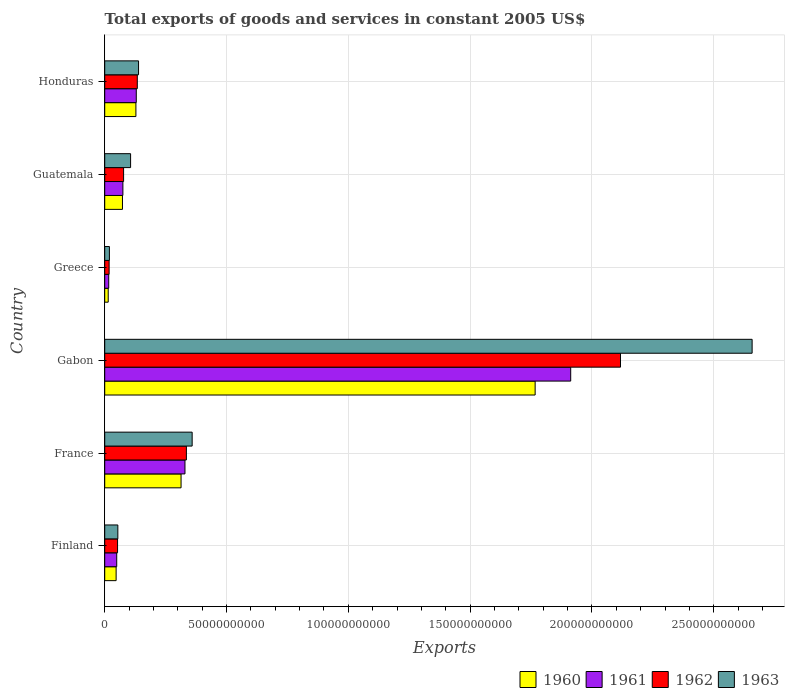How many groups of bars are there?
Your response must be concise. 6. Are the number of bars per tick equal to the number of legend labels?
Make the answer very short. Yes. Are the number of bars on each tick of the Y-axis equal?
Provide a short and direct response. Yes. How many bars are there on the 2nd tick from the bottom?
Provide a succinct answer. 4. What is the label of the 4th group of bars from the top?
Your answer should be compact. Gabon. What is the total exports of goods and services in 1961 in Gabon?
Keep it short and to the point. 1.91e+11. Across all countries, what is the maximum total exports of goods and services in 1961?
Give a very brief answer. 1.91e+11. Across all countries, what is the minimum total exports of goods and services in 1961?
Keep it short and to the point. 1.64e+09. In which country was the total exports of goods and services in 1963 maximum?
Your answer should be very brief. Gabon. In which country was the total exports of goods and services in 1961 minimum?
Provide a succinct answer. Greece. What is the total total exports of goods and services in 1962 in the graph?
Offer a very short reply. 2.73e+11. What is the difference between the total exports of goods and services in 1962 in France and that in Guatemala?
Ensure brevity in your answer.  2.58e+1. What is the difference between the total exports of goods and services in 1960 in Gabon and the total exports of goods and services in 1961 in Finland?
Ensure brevity in your answer.  1.72e+11. What is the average total exports of goods and services in 1960 per country?
Give a very brief answer. 3.90e+1. What is the difference between the total exports of goods and services in 1963 and total exports of goods and services in 1962 in Guatemala?
Your answer should be compact. 2.88e+09. In how many countries, is the total exports of goods and services in 1962 greater than 130000000000 US$?
Ensure brevity in your answer.  1. What is the ratio of the total exports of goods and services in 1963 in France to that in Guatemala?
Provide a short and direct response. 3.38. What is the difference between the highest and the second highest total exports of goods and services in 1960?
Provide a short and direct response. 1.45e+11. What is the difference between the highest and the lowest total exports of goods and services in 1962?
Your answer should be compact. 2.10e+11. Is the sum of the total exports of goods and services in 1962 in Gabon and Greece greater than the maximum total exports of goods and services in 1961 across all countries?
Offer a very short reply. Yes. Is it the case that in every country, the sum of the total exports of goods and services in 1961 and total exports of goods and services in 1960 is greater than the total exports of goods and services in 1962?
Your response must be concise. Yes. Are all the bars in the graph horizontal?
Provide a succinct answer. Yes. Where does the legend appear in the graph?
Provide a short and direct response. Bottom right. How many legend labels are there?
Provide a succinct answer. 4. How are the legend labels stacked?
Keep it short and to the point. Horizontal. What is the title of the graph?
Your answer should be compact. Total exports of goods and services in constant 2005 US$. Does "2008" appear as one of the legend labels in the graph?
Offer a very short reply. No. What is the label or title of the X-axis?
Provide a short and direct response. Exports. What is the label or title of the Y-axis?
Your answer should be very brief. Country. What is the Exports in 1960 in Finland?
Provide a succinct answer. 4.68e+09. What is the Exports in 1961 in Finland?
Your answer should be very brief. 4.92e+09. What is the Exports of 1962 in Finland?
Provide a short and direct response. 5.27e+09. What is the Exports of 1963 in Finland?
Provide a short and direct response. 5.39e+09. What is the Exports of 1960 in France?
Ensure brevity in your answer.  3.13e+1. What is the Exports of 1961 in France?
Offer a terse response. 3.29e+1. What is the Exports of 1962 in France?
Offer a terse response. 3.35e+1. What is the Exports in 1963 in France?
Your answer should be very brief. 3.59e+1. What is the Exports in 1960 in Gabon?
Make the answer very short. 1.77e+11. What is the Exports of 1961 in Gabon?
Your response must be concise. 1.91e+11. What is the Exports of 1962 in Gabon?
Offer a very short reply. 2.12e+11. What is the Exports of 1963 in Gabon?
Give a very brief answer. 2.66e+11. What is the Exports in 1960 in Greece?
Your answer should be very brief. 1.43e+09. What is the Exports in 1961 in Greece?
Offer a very short reply. 1.64e+09. What is the Exports of 1962 in Greece?
Provide a short and direct response. 1.81e+09. What is the Exports in 1963 in Greece?
Provide a succinct answer. 1.93e+09. What is the Exports of 1960 in Guatemala?
Provide a succinct answer. 7.29e+09. What is the Exports in 1961 in Guatemala?
Offer a terse response. 7.46e+09. What is the Exports in 1962 in Guatemala?
Offer a terse response. 7.75e+09. What is the Exports of 1963 in Guatemala?
Give a very brief answer. 1.06e+1. What is the Exports of 1960 in Honduras?
Offer a terse response. 1.28e+1. What is the Exports in 1961 in Honduras?
Your answer should be compact. 1.30e+1. What is the Exports in 1962 in Honduras?
Your answer should be compact. 1.34e+1. What is the Exports in 1963 in Honduras?
Offer a terse response. 1.39e+1. Across all countries, what is the maximum Exports in 1960?
Make the answer very short. 1.77e+11. Across all countries, what is the maximum Exports in 1961?
Keep it short and to the point. 1.91e+11. Across all countries, what is the maximum Exports in 1962?
Your answer should be compact. 2.12e+11. Across all countries, what is the maximum Exports in 1963?
Your response must be concise. 2.66e+11. Across all countries, what is the minimum Exports of 1960?
Make the answer very short. 1.43e+09. Across all countries, what is the minimum Exports of 1961?
Provide a short and direct response. 1.64e+09. Across all countries, what is the minimum Exports in 1962?
Your answer should be compact. 1.81e+09. Across all countries, what is the minimum Exports in 1963?
Keep it short and to the point. 1.93e+09. What is the total Exports of 1960 in the graph?
Make the answer very short. 2.34e+11. What is the total Exports in 1961 in the graph?
Ensure brevity in your answer.  2.51e+11. What is the total Exports in 1962 in the graph?
Give a very brief answer. 2.73e+11. What is the total Exports of 1963 in the graph?
Keep it short and to the point. 3.33e+11. What is the difference between the Exports in 1960 in Finland and that in France?
Offer a very short reply. -2.67e+1. What is the difference between the Exports of 1961 in Finland and that in France?
Give a very brief answer. -2.80e+1. What is the difference between the Exports in 1962 in Finland and that in France?
Ensure brevity in your answer.  -2.83e+1. What is the difference between the Exports in 1963 in Finland and that in France?
Your answer should be very brief. -3.05e+1. What is the difference between the Exports in 1960 in Finland and that in Gabon?
Provide a succinct answer. -1.72e+11. What is the difference between the Exports of 1961 in Finland and that in Gabon?
Offer a very short reply. -1.86e+11. What is the difference between the Exports of 1962 in Finland and that in Gabon?
Offer a terse response. -2.06e+11. What is the difference between the Exports in 1963 in Finland and that in Gabon?
Give a very brief answer. -2.60e+11. What is the difference between the Exports in 1960 in Finland and that in Greece?
Offer a terse response. 3.25e+09. What is the difference between the Exports of 1961 in Finland and that in Greece?
Your answer should be very brief. 3.28e+09. What is the difference between the Exports of 1962 in Finland and that in Greece?
Your response must be concise. 3.46e+09. What is the difference between the Exports in 1963 in Finland and that in Greece?
Offer a very short reply. 3.46e+09. What is the difference between the Exports in 1960 in Finland and that in Guatemala?
Your answer should be very brief. -2.61e+09. What is the difference between the Exports in 1961 in Finland and that in Guatemala?
Provide a short and direct response. -2.54e+09. What is the difference between the Exports in 1962 in Finland and that in Guatemala?
Offer a very short reply. -2.47e+09. What is the difference between the Exports of 1963 in Finland and that in Guatemala?
Make the answer very short. -5.24e+09. What is the difference between the Exports of 1960 in Finland and that in Honduras?
Offer a terse response. -8.12e+09. What is the difference between the Exports in 1961 in Finland and that in Honduras?
Provide a short and direct response. -8.03e+09. What is the difference between the Exports of 1962 in Finland and that in Honduras?
Offer a terse response. -8.10e+09. What is the difference between the Exports of 1963 in Finland and that in Honduras?
Your answer should be compact. -8.50e+09. What is the difference between the Exports in 1960 in France and that in Gabon?
Your answer should be compact. -1.45e+11. What is the difference between the Exports of 1961 in France and that in Gabon?
Provide a succinct answer. -1.58e+11. What is the difference between the Exports in 1962 in France and that in Gabon?
Provide a short and direct response. -1.78e+11. What is the difference between the Exports of 1963 in France and that in Gabon?
Your answer should be compact. -2.30e+11. What is the difference between the Exports of 1960 in France and that in Greece?
Give a very brief answer. 2.99e+1. What is the difference between the Exports in 1961 in France and that in Greece?
Offer a terse response. 3.13e+1. What is the difference between the Exports in 1962 in France and that in Greece?
Your answer should be compact. 3.17e+1. What is the difference between the Exports of 1963 in France and that in Greece?
Keep it short and to the point. 3.40e+1. What is the difference between the Exports in 1960 in France and that in Guatemala?
Make the answer very short. 2.40e+1. What is the difference between the Exports of 1961 in France and that in Guatemala?
Provide a succinct answer. 2.55e+1. What is the difference between the Exports of 1962 in France and that in Guatemala?
Your answer should be very brief. 2.58e+1. What is the difference between the Exports of 1963 in France and that in Guatemala?
Provide a short and direct response. 2.53e+1. What is the difference between the Exports of 1960 in France and that in Honduras?
Offer a very short reply. 1.85e+1. What is the difference between the Exports of 1961 in France and that in Honduras?
Your answer should be very brief. 2.00e+1. What is the difference between the Exports in 1962 in France and that in Honduras?
Give a very brief answer. 2.01e+1. What is the difference between the Exports in 1963 in France and that in Honduras?
Ensure brevity in your answer.  2.20e+1. What is the difference between the Exports of 1960 in Gabon and that in Greece?
Offer a terse response. 1.75e+11. What is the difference between the Exports in 1961 in Gabon and that in Greece?
Your answer should be compact. 1.90e+11. What is the difference between the Exports of 1962 in Gabon and that in Greece?
Offer a terse response. 2.10e+11. What is the difference between the Exports of 1963 in Gabon and that in Greece?
Provide a succinct answer. 2.64e+11. What is the difference between the Exports of 1960 in Gabon and that in Guatemala?
Offer a very short reply. 1.69e+11. What is the difference between the Exports in 1961 in Gabon and that in Guatemala?
Give a very brief answer. 1.84e+11. What is the difference between the Exports in 1962 in Gabon and that in Guatemala?
Give a very brief answer. 2.04e+11. What is the difference between the Exports of 1963 in Gabon and that in Guatemala?
Offer a terse response. 2.55e+11. What is the difference between the Exports of 1960 in Gabon and that in Honduras?
Give a very brief answer. 1.64e+11. What is the difference between the Exports of 1961 in Gabon and that in Honduras?
Keep it short and to the point. 1.78e+11. What is the difference between the Exports in 1962 in Gabon and that in Honduras?
Provide a succinct answer. 1.98e+11. What is the difference between the Exports of 1963 in Gabon and that in Honduras?
Keep it short and to the point. 2.52e+11. What is the difference between the Exports of 1960 in Greece and that in Guatemala?
Ensure brevity in your answer.  -5.85e+09. What is the difference between the Exports of 1961 in Greece and that in Guatemala?
Keep it short and to the point. -5.82e+09. What is the difference between the Exports in 1962 in Greece and that in Guatemala?
Provide a short and direct response. -5.94e+09. What is the difference between the Exports of 1963 in Greece and that in Guatemala?
Make the answer very short. -8.70e+09. What is the difference between the Exports of 1960 in Greece and that in Honduras?
Your answer should be compact. -1.14e+1. What is the difference between the Exports in 1961 in Greece and that in Honduras?
Make the answer very short. -1.13e+1. What is the difference between the Exports of 1962 in Greece and that in Honduras?
Provide a succinct answer. -1.16e+1. What is the difference between the Exports in 1963 in Greece and that in Honduras?
Offer a terse response. -1.20e+1. What is the difference between the Exports of 1960 in Guatemala and that in Honduras?
Your answer should be very brief. -5.51e+09. What is the difference between the Exports of 1961 in Guatemala and that in Honduras?
Offer a terse response. -5.49e+09. What is the difference between the Exports in 1962 in Guatemala and that in Honduras?
Offer a terse response. -5.63e+09. What is the difference between the Exports in 1963 in Guatemala and that in Honduras?
Ensure brevity in your answer.  -3.26e+09. What is the difference between the Exports in 1960 in Finland and the Exports in 1961 in France?
Keep it short and to the point. -2.83e+1. What is the difference between the Exports of 1960 in Finland and the Exports of 1962 in France?
Provide a short and direct response. -2.88e+1. What is the difference between the Exports of 1960 in Finland and the Exports of 1963 in France?
Your answer should be very brief. -3.12e+1. What is the difference between the Exports of 1961 in Finland and the Exports of 1962 in France?
Give a very brief answer. -2.86e+1. What is the difference between the Exports in 1961 in Finland and the Exports in 1963 in France?
Ensure brevity in your answer.  -3.10e+1. What is the difference between the Exports of 1962 in Finland and the Exports of 1963 in France?
Your response must be concise. -3.06e+1. What is the difference between the Exports in 1960 in Finland and the Exports in 1961 in Gabon?
Offer a very short reply. -1.87e+11. What is the difference between the Exports of 1960 in Finland and the Exports of 1962 in Gabon?
Give a very brief answer. -2.07e+11. What is the difference between the Exports in 1960 in Finland and the Exports in 1963 in Gabon?
Offer a terse response. -2.61e+11. What is the difference between the Exports in 1961 in Finland and the Exports in 1962 in Gabon?
Your response must be concise. -2.07e+11. What is the difference between the Exports in 1961 in Finland and the Exports in 1963 in Gabon?
Ensure brevity in your answer.  -2.61e+11. What is the difference between the Exports in 1962 in Finland and the Exports in 1963 in Gabon?
Keep it short and to the point. -2.60e+11. What is the difference between the Exports of 1960 in Finland and the Exports of 1961 in Greece?
Provide a short and direct response. 3.04e+09. What is the difference between the Exports in 1960 in Finland and the Exports in 1962 in Greece?
Give a very brief answer. 2.88e+09. What is the difference between the Exports in 1960 in Finland and the Exports in 1963 in Greece?
Give a very brief answer. 2.76e+09. What is the difference between the Exports of 1961 in Finland and the Exports of 1962 in Greece?
Provide a short and direct response. 3.12e+09. What is the difference between the Exports in 1961 in Finland and the Exports in 1963 in Greece?
Provide a succinct answer. 3.00e+09. What is the difference between the Exports in 1962 in Finland and the Exports in 1963 in Greece?
Make the answer very short. 3.34e+09. What is the difference between the Exports in 1960 in Finland and the Exports in 1961 in Guatemala?
Offer a terse response. -2.78e+09. What is the difference between the Exports in 1960 in Finland and the Exports in 1962 in Guatemala?
Your response must be concise. -3.06e+09. What is the difference between the Exports in 1960 in Finland and the Exports in 1963 in Guatemala?
Provide a short and direct response. -5.94e+09. What is the difference between the Exports of 1961 in Finland and the Exports of 1962 in Guatemala?
Offer a very short reply. -2.82e+09. What is the difference between the Exports of 1961 in Finland and the Exports of 1963 in Guatemala?
Your answer should be compact. -5.70e+09. What is the difference between the Exports in 1962 in Finland and the Exports in 1963 in Guatemala?
Offer a terse response. -5.35e+09. What is the difference between the Exports in 1960 in Finland and the Exports in 1961 in Honduras?
Ensure brevity in your answer.  -8.27e+09. What is the difference between the Exports in 1960 in Finland and the Exports in 1962 in Honduras?
Your answer should be very brief. -8.69e+09. What is the difference between the Exports in 1960 in Finland and the Exports in 1963 in Honduras?
Your answer should be compact. -9.20e+09. What is the difference between the Exports of 1961 in Finland and the Exports of 1962 in Honduras?
Provide a short and direct response. -8.45e+09. What is the difference between the Exports of 1961 in Finland and the Exports of 1963 in Honduras?
Provide a short and direct response. -8.96e+09. What is the difference between the Exports in 1962 in Finland and the Exports in 1963 in Honduras?
Keep it short and to the point. -8.61e+09. What is the difference between the Exports of 1960 in France and the Exports of 1961 in Gabon?
Your answer should be very brief. -1.60e+11. What is the difference between the Exports of 1960 in France and the Exports of 1962 in Gabon?
Your answer should be very brief. -1.80e+11. What is the difference between the Exports of 1960 in France and the Exports of 1963 in Gabon?
Keep it short and to the point. -2.34e+11. What is the difference between the Exports in 1961 in France and the Exports in 1962 in Gabon?
Ensure brevity in your answer.  -1.79e+11. What is the difference between the Exports of 1961 in France and the Exports of 1963 in Gabon?
Provide a short and direct response. -2.33e+11. What is the difference between the Exports of 1962 in France and the Exports of 1963 in Gabon?
Offer a terse response. -2.32e+11. What is the difference between the Exports in 1960 in France and the Exports in 1961 in Greece?
Ensure brevity in your answer.  2.97e+1. What is the difference between the Exports of 1960 in France and the Exports of 1962 in Greece?
Your answer should be compact. 2.95e+1. What is the difference between the Exports of 1960 in France and the Exports of 1963 in Greece?
Ensure brevity in your answer.  2.94e+1. What is the difference between the Exports in 1961 in France and the Exports in 1962 in Greece?
Keep it short and to the point. 3.11e+1. What is the difference between the Exports in 1961 in France and the Exports in 1963 in Greece?
Ensure brevity in your answer.  3.10e+1. What is the difference between the Exports in 1962 in France and the Exports in 1963 in Greece?
Provide a short and direct response. 3.16e+1. What is the difference between the Exports of 1960 in France and the Exports of 1961 in Guatemala?
Your response must be concise. 2.39e+1. What is the difference between the Exports in 1960 in France and the Exports in 1962 in Guatemala?
Offer a terse response. 2.36e+1. What is the difference between the Exports of 1960 in France and the Exports of 1963 in Guatemala?
Provide a short and direct response. 2.07e+1. What is the difference between the Exports of 1961 in France and the Exports of 1962 in Guatemala?
Offer a terse response. 2.52e+1. What is the difference between the Exports of 1961 in France and the Exports of 1963 in Guatemala?
Offer a very short reply. 2.23e+1. What is the difference between the Exports in 1962 in France and the Exports in 1963 in Guatemala?
Give a very brief answer. 2.29e+1. What is the difference between the Exports of 1960 in France and the Exports of 1961 in Honduras?
Your response must be concise. 1.84e+1. What is the difference between the Exports in 1960 in France and the Exports in 1962 in Honduras?
Give a very brief answer. 1.80e+1. What is the difference between the Exports of 1960 in France and the Exports of 1963 in Honduras?
Keep it short and to the point. 1.74e+1. What is the difference between the Exports of 1961 in France and the Exports of 1962 in Honduras?
Keep it short and to the point. 1.96e+1. What is the difference between the Exports in 1961 in France and the Exports in 1963 in Honduras?
Make the answer very short. 1.91e+1. What is the difference between the Exports in 1962 in France and the Exports in 1963 in Honduras?
Make the answer very short. 1.96e+1. What is the difference between the Exports of 1960 in Gabon and the Exports of 1961 in Greece?
Your answer should be compact. 1.75e+11. What is the difference between the Exports in 1960 in Gabon and the Exports in 1962 in Greece?
Provide a succinct answer. 1.75e+11. What is the difference between the Exports of 1960 in Gabon and the Exports of 1963 in Greece?
Make the answer very short. 1.75e+11. What is the difference between the Exports in 1961 in Gabon and the Exports in 1962 in Greece?
Ensure brevity in your answer.  1.89e+11. What is the difference between the Exports of 1961 in Gabon and the Exports of 1963 in Greece?
Provide a short and direct response. 1.89e+11. What is the difference between the Exports in 1962 in Gabon and the Exports in 1963 in Greece?
Your response must be concise. 2.10e+11. What is the difference between the Exports of 1960 in Gabon and the Exports of 1961 in Guatemala?
Give a very brief answer. 1.69e+11. What is the difference between the Exports in 1960 in Gabon and the Exports in 1962 in Guatemala?
Your response must be concise. 1.69e+11. What is the difference between the Exports of 1960 in Gabon and the Exports of 1963 in Guatemala?
Give a very brief answer. 1.66e+11. What is the difference between the Exports of 1961 in Gabon and the Exports of 1962 in Guatemala?
Your answer should be very brief. 1.84e+11. What is the difference between the Exports in 1961 in Gabon and the Exports in 1963 in Guatemala?
Your response must be concise. 1.81e+11. What is the difference between the Exports of 1962 in Gabon and the Exports of 1963 in Guatemala?
Keep it short and to the point. 2.01e+11. What is the difference between the Exports of 1960 in Gabon and the Exports of 1961 in Honduras?
Your response must be concise. 1.64e+11. What is the difference between the Exports of 1960 in Gabon and the Exports of 1962 in Honduras?
Your response must be concise. 1.63e+11. What is the difference between the Exports in 1960 in Gabon and the Exports in 1963 in Honduras?
Provide a succinct answer. 1.63e+11. What is the difference between the Exports of 1961 in Gabon and the Exports of 1962 in Honduras?
Provide a short and direct response. 1.78e+11. What is the difference between the Exports of 1961 in Gabon and the Exports of 1963 in Honduras?
Keep it short and to the point. 1.77e+11. What is the difference between the Exports of 1962 in Gabon and the Exports of 1963 in Honduras?
Keep it short and to the point. 1.98e+11. What is the difference between the Exports in 1960 in Greece and the Exports in 1961 in Guatemala?
Make the answer very short. -6.02e+09. What is the difference between the Exports in 1960 in Greece and the Exports in 1962 in Guatemala?
Your answer should be compact. -6.31e+09. What is the difference between the Exports in 1960 in Greece and the Exports in 1963 in Guatemala?
Make the answer very short. -9.19e+09. What is the difference between the Exports in 1961 in Greece and the Exports in 1962 in Guatemala?
Offer a very short reply. -6.10e+09. What is the difference between the Exports in 1961 in Greece and the Exports in 1963 in Guatemala?
Make the answer very short. -8.98e+09. What is the difference between the Exports of 1962 in Greece and the Exports of 1963 in Guatemala?
Offer a terse response. -8.82e+09. What is the difference between the Exports of 1960 in Greece and the Exports of 1961 in Honduras?
Keep it short and to the point. -1.15e+1. What is the difference between the Exports of 1960 in Greece and the Exports of 1962 in Honduras?
Make the answer very short. -1.19e+1. What is the difference between the Exports in 1960 in Greece and the Exports in 1963 in Honduras?
Your answer should be compact. -1.25e+1. What is the difference between the Exports of 1961 in Greece and the Exports of 1962 in Honduras?
Provide a succinct answer. -1.17e+1. What is the difference between the Exports of 1961 in Greece and the Exports of 1963 in Honduras?
Keep it short and to the point. -1.22e+1. What is the difference between the Exports in 1962 in Greece and the Exports in 1963 in Honduras?
Provide a succinct answer. -1.21e+1. What is the difference between the Exports in 1960 in Guatemala and the Exports in 1961 in Honduras?
Your answer should be compact. -5.66e+09. What is the difference between the Exports in 1960 in Guatemala and the Exports in 1962 in Honduras?
Offer a terse response. -6.09e+09. What is the difference between the Exports in 1960 in Guatemala and the Exports in 1963 in Honduras?
Give a very brief answer. -6.60e+09. What is the difference between the Exports of 1961 in Guatemala and the Exports of 1962 in Honduras?
Provide a succinct answer. -5.92e+09. What is the difference between the Exports in 1961 in Guatemala and the Exports in 1963 in Honduras?
Provide a succinct answer. -6.43e+09. What is the difference between the Exports of 1962 in Guatemala and the Exports of 1963 in Honduras?
Give a very brief answer. -6.14e+09. What is the average Exports in 1960 per country?
Your answer should be compact. 3.90e+1. What is the average Exports in 1961 per country?
Your response must be concise. 4.19e+1. What is the average Exports of 1962 per country?
Your response must be concise. 4.56e+1. What is the average Exports in 1963 per country?
Your answer should be compact. 5.56e+1. What is the difference between the Exports of 1960 and Exports of 1961 in Finland?
Provide a succinct answer. -2.41e+08. What is the difference between the Exports in 1960 and Exports in 1962 in Finland?
Give a very brief answer. -5.89e+08. What is the difference between the Exports in 1960 and Exports in 1963 in Finland?
Your answer should be compact. -7.04e+08. What is the difference between the Exports in 1961 and Exports in 1962 in Finland?
Provide a short and direct response. -3.48e+08. What is the difference between the Exports of 1961 and Exports of 1963 in Finland?
Offer a very short reply. -4.64e+08. What is the difference between the Exports of 1962 and Exports of 1963 in Finland?
Your answer should be very brief. -1.15e+08. What is the difference between the Exports in 1960 and Exports in 1961 in France?
Your answer should be compact. -1.60e+09. What is the difference between the Exports of 1960 and Exports of 1962 in France?
Keep it short and to the point. -2.19e+09. What is the difference between the Exports in 1960 and Exports in 1963 in France?
Your answer should be compact. -4.55e+09. What is the difference between the Exports of 1961 and Exports of 1962 in France?
Make the answer very short. -5.82e+08. What is the difference between the Exports in 1961 and Exports in 1963 in France?
Your response must be concise. -2.95e+09. What is the difference between the Exports of 1962 and Exports of 1963 in France?
Give a very brief answer. -2.37e+09. What is the difference between the Exports of 1960 and Exports of 1961 in Gabon?
Your answer should be very brief. -1.46e+1. What is the difference between the Exports of 1960 and Exports of 1962 in Gabon?
Keep it short and to the point. -3.50e+1. What is the difference between the Exports of 1960 and Exports of 1963 in Gabon?
Your answer should be compact. -8.91e+1. What is the difference between the Exports in 1961 and Exports in 1962 in Gabon?
Give a very brief answer. -2.04e+1. What is the difference between the Exports of 1961 and Exports of 1963 in Gabon?
Make the answer very short. -7.45e+1. What is the difference between the Exports in 1962 and Exports in 1963 in Gabon?
Give a very brief answer. -5.40e+1. What is the difference between the Exports in 1960 and Exports in 1961 in Greece?
Keep it short and to the point. -2.08e+08. What is the difference between the Exports of 1960 and Exports of 1962 in Greece?
Your answer should be compact. -3.72e+08. What is the difference between the Exports in 1960 and Exports in 1963 in Greece?
Give a very brief answer. -4.92e+08. What is the difference between the Exports of 1961 and Exports of 1962 in Greece?
Provide a succinct answer. -1.64e+08. What is the difference between the Exports of 1961 and Exports of 1963 in Greece?
Make the answer very short. -2.84e+08. What is the difference between the Exports in 1962 and Exports in 1963 in Greece?
Ensure brevity in your answer.  -1.20e+08. What is the difference between the Exports in 1960 and Exports in 1961 in Guatemala?
Your answer should be very brief. -1.71e+08. What is the difference between the Exports in 1960 and Exports in 1962 in Guatemala?
Provide a short and direct response. -4.57e+08. What is the difference between the Exports in 1960 and Exports in 1963 in Guatemala?
Your answer should be compact. -3.33e+09. What is the difference between the Exports of 1961 and Exports of 1962 in Guatemala?
Provide a succinct answer. -2.86e+08. What is the difference between the Exports of 1961 and Exports of 1963 in Guatemala?
Provide a short and direct response. -3.16e+09. What is the difference between the Exports in 1962 and Exports in 1963 in Guatemala?
Ensure brevity in your answer.  -2.88e+09. What is the difference between the Exports in 1960 and Exports in 1961 in Honduras?
Your answer should be very brief. -1.52e+08. What is the difference between the Exports in 1960 and Exports in 1962 in Honduras?
Offer a very short reply. -5.74e+08. What is the difference between the Exports of 1960 and Exports of 1963 in Honduras?
Offer a terse response. -1.09e+09. What is the difference between the Exports of 1961 and Exports of 1962 in Honduras?
Your answer should be compact. -4.22e+08. What is the difference between the Exports in 1961 and Exports in 1963 in Honduras?
Your answer should be very brief. -9.34e+08. What is the difference between the Exports of 1962 and Exports of 1963 in Honduras?
Your response must be concise. -5.12e+08. What is the ratio of the Exports of 1960 in Finland to that in France?
Your response must be concise. 0.15. What is the ratio of the Exports in 1961 in Finland to that in France?
Your response must be concise. 0.15. What is the ratio of the Exports of 1962 in Finland to that in France?
Provide a short and direct response. 0.16. What is the ratio of the Exports in 1963 in Finland to that in France?
Provide a succinct answer. 0.15. What is the ratio of the Exports in 1960 in Finland to that in Gabon?
Give a very brief answer. 0.03. What is the ratio of the Exports in 1961 in Finland to that in Gabon?
Your answer should be very brief. 0.03. What is the ratio of the Exports of 1962 in Finland to that in Gabon?
Your response must be concise. 0.02. What is the ratio of the Exports of 1963 in Finland to that in Gabon?
Provide a short and direct response. 0.02. What is the ratio of the Exports in 1960 in Finland to that in Greece?
Your answer should be compact. 3.26. What is the ratio of the Exports in 1961 in Finland to that in Greece?
Offer a very short reply. 3. What is the ratio of the Exports in 1962 in Finland to that in Greece?
Your response must be concise. 2.92. What is the ratio of the Exports of 1963 in Finland to that in Greece?
Provide a short and direct response. 2.8. What is the ratio of the Exports in 1960 in Finland to that in Guatemala?
Your response must be concise. 0.64. What is the ratio of the Exports of 1961 in Finland to that in Guatemala?
Ensure brevity in your answer.  0.66. What is the ratio of the Exports of 1962 in Finland to that in Guatemala?
Offer a very short reply. 0.68. What is the ratio of the Exports of 1963 in Finland to that in Guatemala?
Your answer should be very brief. 0.51. What is the ratio of the Exports of 1960 in Finland to that in Honduras?
Offer a terse response. 0.37. What is the ratio of the Exports of 1961 in Finland to that in Honduras?
Offer a very short reply. 0.38. What is the ratio of the Exports of 1962 in Finland to that in Honduras?
Your answer should be compact. 0.39. What is the ratio of the Exports of 1963 in Finland to that in Honduras?
Keep it short and to the point. 0.39. What is the ratio of the Exports of 1960 in France to that in Gabon?
Offer a terse response. 0.18. What is the ratio of the Exports in 1961 in France to that in Gabon?
Your answer should be very brief. 0.17. What is the ratio of the Exports of 1962 in France to that in Gabon?
Offer a terse response. 0.16. What is the ratio of the Exports of 1963 in France to that in Gabon?
Offer a terse response. 0.14. What is the ratio of the Exports of 1960 in France to that in Greece?
Your answer should be compact. 21.84. What is the ratio of the Exports in 1961 in France to that in Greece?
Offer a terse response. 20.05. What is the ratio of the Exports in 1962 in France to that in Greece?
Provide a short and direct response. 18.55. What is the ratio of the Exports of 1963 in France to that in Greece?
Your answer should be compact. 18.62. What is the ratio of the Exports in 1960 in France to that in Guatemala?
Make the answer very short. 4.3. What is the ratio of the Exports of 1961 in France to that in Guatemala?
Your response must be concise. 4.42. What is the ratio of the Exports of 1962 in France to that in Guatemala?
Your answer should be compact. 4.33. What is the ratio of the Exports in 1963 in France to that in Guatemala?
Provide a succinct answer. 3.38. What is the ratio of the Exports in 1960 in France to that in Honduras?
Provide a succinct answer. 2.45. What is the ratio of the Exports of 1961 in France to that in Honduras?
Your answer should be compact. 2.54. What is the ratio of the Exports in 1962 in France to that in Honduras?
Ensure brevity in your answer.  2.51. What is the ratio of the Exports in 1963 in France to that in Honduras?
Keep it short and to the point. 2.58. What is the ratio of the Exports of 1960 in Gabon to that in Greece?
Keep it short and to the point. 123.12. What is the ratio of the Exports in 1961 in Gabon to that in Greece?
Offer a terse response. 116.39. What is the ratio of the Exports in 1962 in Gabon to that in Greece?
Keep it short and to the point. 117.16. What is the ratio of the Exports of 1963 in Gabon to that in Greece?
Your answer should be compact. 137.87. What is the ratio of the Exports of 1960 in Gabon to that in Guatemala?
Your response must be concise. 24.24. What is the ratio of the Exports in 1961 in Gabon to that in Guatemala?
Provide a short and direct response. 25.64. What is the ratio of the Exports of 1962 in Gabon to that in Guatemala?
Provide a short and direct response. 27.33. What is the ratio of the Exports in 1963 in Gabon to that in Guatemala?
Offer a terse response. 25.02. What is the ratio of the Exports of 1960 in Gabon to that in Honduras?
Provide a short and direct response. 13.8. What is the ratio of the Exports of 1961 in Gabon to that in Honduras?
Offer a very short reply. 14.77. What is the ratio of the Exports of 1962 in Gabon to that in Honduras?
Give a very brief answer. 15.83. What is the ratio of the Exports in 1963 in Gabon to that in Honduras?
Your answer should be compact. 19.14. What is the ratio of the Exports of 1960 in Greece to that in Guatemala?
Offer a very short reply. 0.2. What is the ratio of the Exports in 1961 in Greece to that in Guatemala?
Your response must be concise. 0.22. What is the ratio of the Exports of 1962 in Greece to that in Guatemala?
Provide a succinct answer. 0.23. What is the ratio of the Exports of 1963 in Greece to that in Guatemala?
Make the answer very short. 0.18. What is the ratio of the Exports of 1960 in Greece to that in Honduras?
Your answer should be compact. 0.11. What is the ratio of the Exports of 1961 in Greece to that in Honduras?
Offer a terse response. 0.13. What is the ratio of the Exports of 1962 in Greece to that in Honduras?
Keep it short and to the point. 0.14. What is the ratio of the Exports of 1963 in Greece to that in Honduras?
Your answer should be compact. 0.14. What is the ratio of the Exports in 1960 in Guatemala to that in Honduras?
Provide a succinct answer. 0.57. What is the ratio of the Exports of 1961 in Guatemala to that in Honduras?
Make the answer very short. 0.58. What is the ratio of the Exports of 1962 in Guatemala to that in Honduras?
Offer a terse response. 0.58. What is the ratio of the Exports in 1963 in Guatemala to that in Honduras?
Give a very brief answer. 0.76. What is the difference between the highest and the second highest Exports in 1960?
Make the answer very short. 1.45e+11. What is the difference between the highest and the second highest Exports in 1961?
Ensure brevity in your answer.  1.58e+11. What is the difference between the highest and the second highest Exports of 1962?
Ensure brevity in your answer.  1.78e+11. What is the difference between the highest and the second highest Exports in 1963?
Offer a very short reply. 2.30e+11. What is the difference between the highest and the lowest Exports of 1960?
Provide a short and direct response. 1.75e+11. What is the difference between the highest and the lowest Exports in 1961?
Keep it short and to the point. 1.90e+11. What is the difference between the highest and the lowest Exports of 1962?
Give a very brief answer. 2.10e+11. What is the difference between the highest and the lowest Exports in 1963?
Make the answer very short. 2.64e+11. 